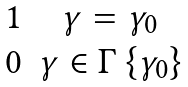<formula> <loc_0><loc_0><loc_500><loc_500>\begin{matrix} 1 & \gamma = \gamma _ { 0 } \\ 0 & \gamma \in \Gamma \ \{ \gamma _ { 0 } \} \end{matrix}</formula> 